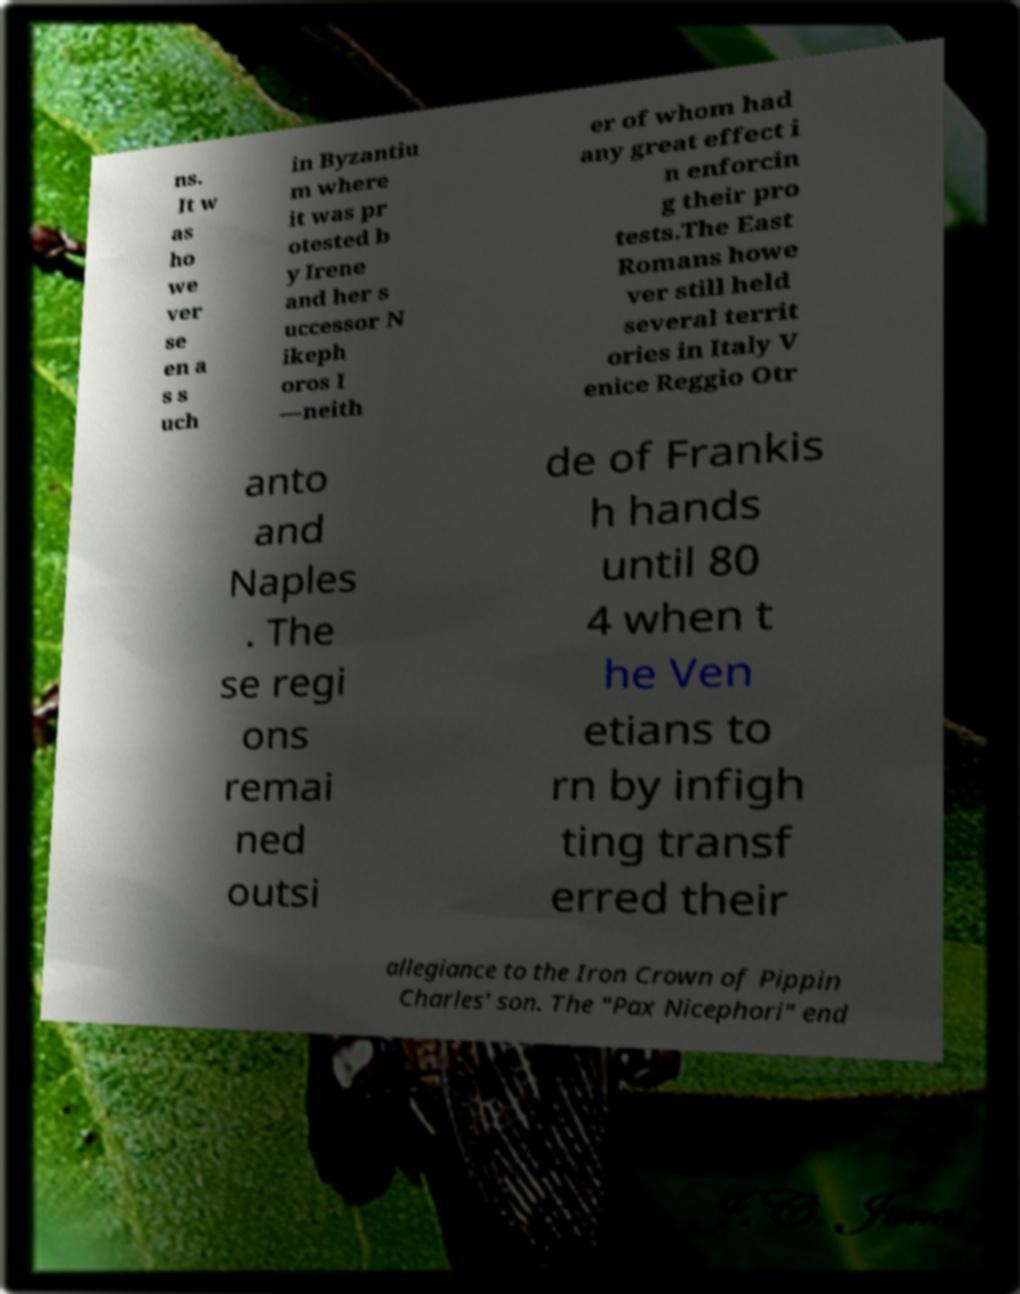Can you accurately transcribe the text from the provided image for me? ns. It w as ho we ver se en a s s uch in Byzantiu m where it was pr otested b y Irene and her s uccessor N ikeph oros I —neith er of whom had any great effect i n enforcin g their pro tests.The East Romans howe ver still held several territ ories in Italy V enice Reggio Otr anto and Naples . The se regi ons remai ned outsi de of Frankis h hands until 80 4 when t he Ven etians to rn by infigh ting transf erred their allegiance to the Iron Crown of Pippin Charles' son. The "Pax Nicephori" end 